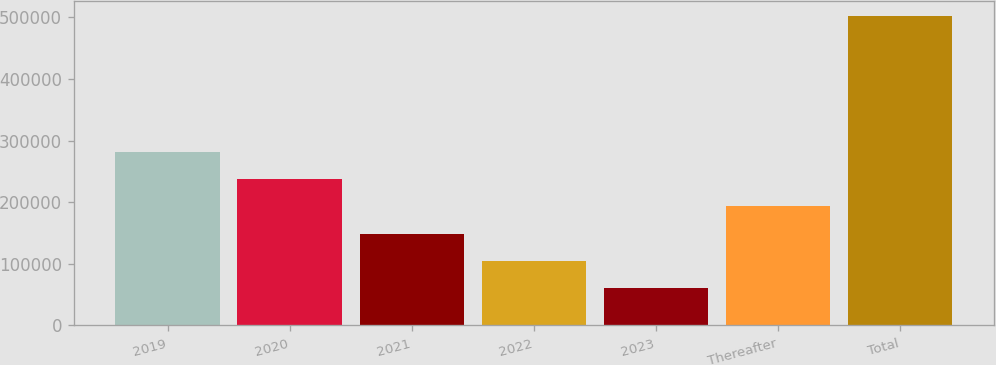Convert chart to OTSL. <chart><loc_0><loc_0><loc_500><loc_500><bar_chart><fcel>2019<fcel>2020<fcel>2021<fcel>2022<fcel>2023<fcel>Thereafter<fcel>Total<nl><fcel>281320<fcel>237269<fcel>149166<fcel>105114<fcel>61063<fcel>193217<fcel>501577<nl></chart> 